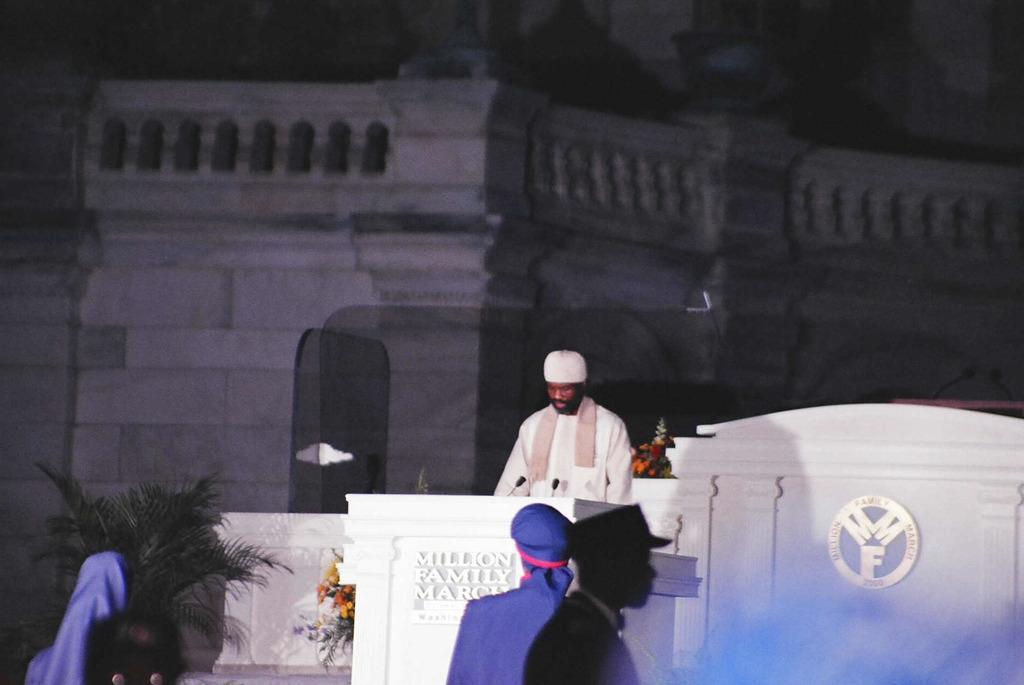In one or two sentences, can you explain what this image depicts? In this image there are four people standing , and there is a person standing near the podium , there are mikes on the podium,building, flower bouquets, plant. 